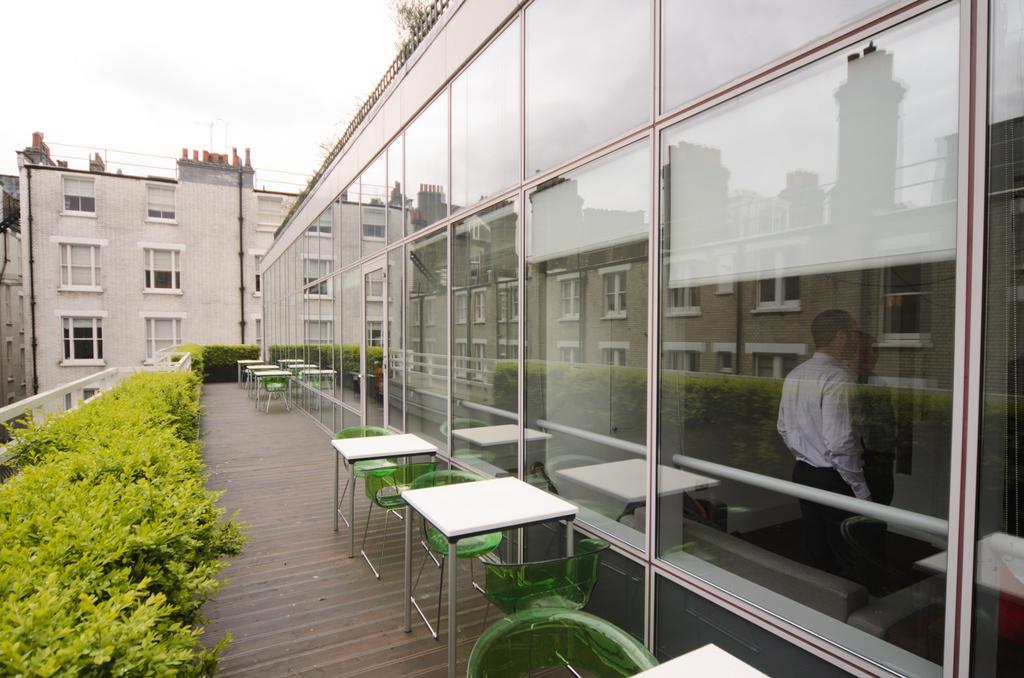How would you summarize this image in a sentence or two? This is the picture of a place where we have a glass room and outside there are some tables and chairs and in front of them there are some plants. 